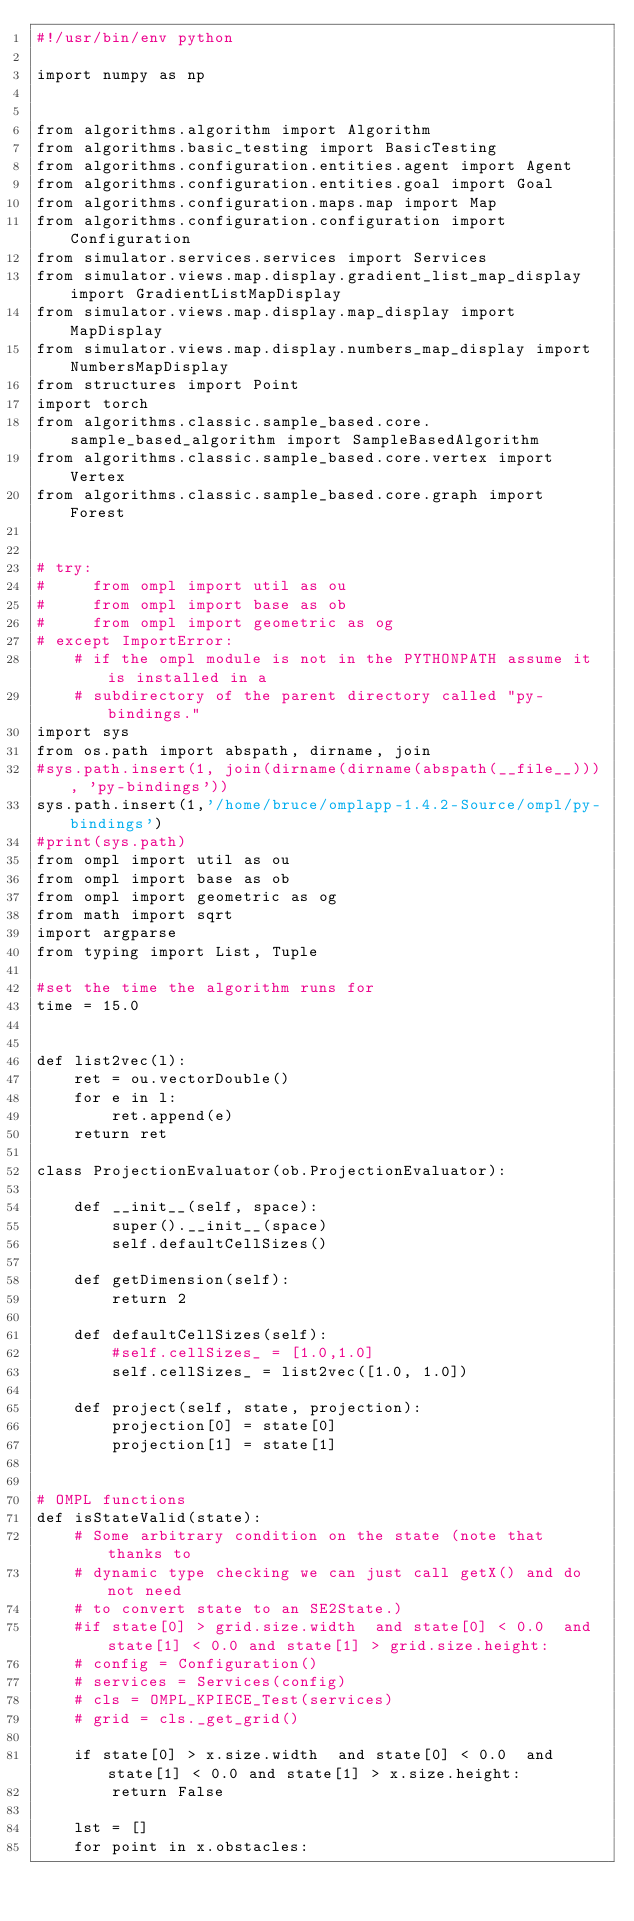<code> <loc_0><loc_0><loc_500><loc_500><_Python_>#!/usr/bin/env python
  
import numpy as np


from algorithms.algorithm import Algorithm
from algorithms.basic_testing import BasicTesting
from algorithms.configuration.entities.agent import Agent
from algorithms.configuration.entities.goal import Goal
from algorithms.configuration.maps.map import Map
from algorithms.configuration.configuration import Configuration
from simulator.services.services import Services
from simulator.views.map.display.gradient_list_map_display import GradientListMapDisplay
from simulator.views.map.display.map_display import MapDisplay
from simulator.views.map.display.numbers_map_display import NumbersMapDisplay
from structures import Point
import torch
from algorithms.classic.sample_based.core.sample_based_algorithm import SampleBasedAlgorithm
from algorithms.classic.sample_based.core.vertex import Vertex
from algorithms.classic.sample_based.core.graph import Forest


# try:
#     from ompl import util as ou
#     from ompl import base as ob
#     from ompl import geometric as og
# except ImportError:
    # if the ompl module is not in the PYTHONPATH assume it is installed in a
    # subdirectory of the parent directory called "py-bindings."
import sys    
from os.path import abspath, dirname, join
#sys.path.insert(1, join(dirname(dirname(abspath(__file__))), 'py-bindings'))
sys.path.insert(1,'/home/bruce/omplapp-1.4.2-Source/ompl/py-bindings')
#print(sys.path)
from ompl import util as ou
from ompl import base as ob
from ompl import geometric as og
from math import sqrt
import argparse
from typing import List, Tuple

#set the time the algorithm runs for
time = 15.0


def list2vec(l):
    ret = ou.vectorDouble()
    for e in l:
        ret.append(e)
    return ret

class ProjectionEvaluator(ob.ProjectionEvaluator):
    
    def __init__(self, space):
        super().__init__(space)
        self.defaultCellSizes()

    def getDimension(self):
        return 2

    def defaultCellSizes(self):
        #self.cellSizes_ = [1.0,1.0]
        self.cellSizes_ = list2vec([1.0, 1.0])

    def project(self, state, projection):
        projection[0] = state[0]
        projection[1] = state[1]


# OMPL functions
def isStateValid(state):
    # Some arbitrary condition on the state (note that thanks to
    # dynamic type checking we can just call getX() and do not need
    # to convert state to an SE2State.)
    #if state[0] > grid.size.width  and state[0] < 0.0  and state[1] < 0.0 and state[1] > grid.size.height:
    # config = Configuration()
    # services = Services(config)   
    # cls = OMPL_KPIECE_Test(services)
    # grid = cls._get_grid()

    if state[0] > x.size.width  and state[0] < 0.0  and state[1] < 0.0 and state[1] > x.size.height:
        return False

    lst = []
    for point in x.obstacles:</code> 